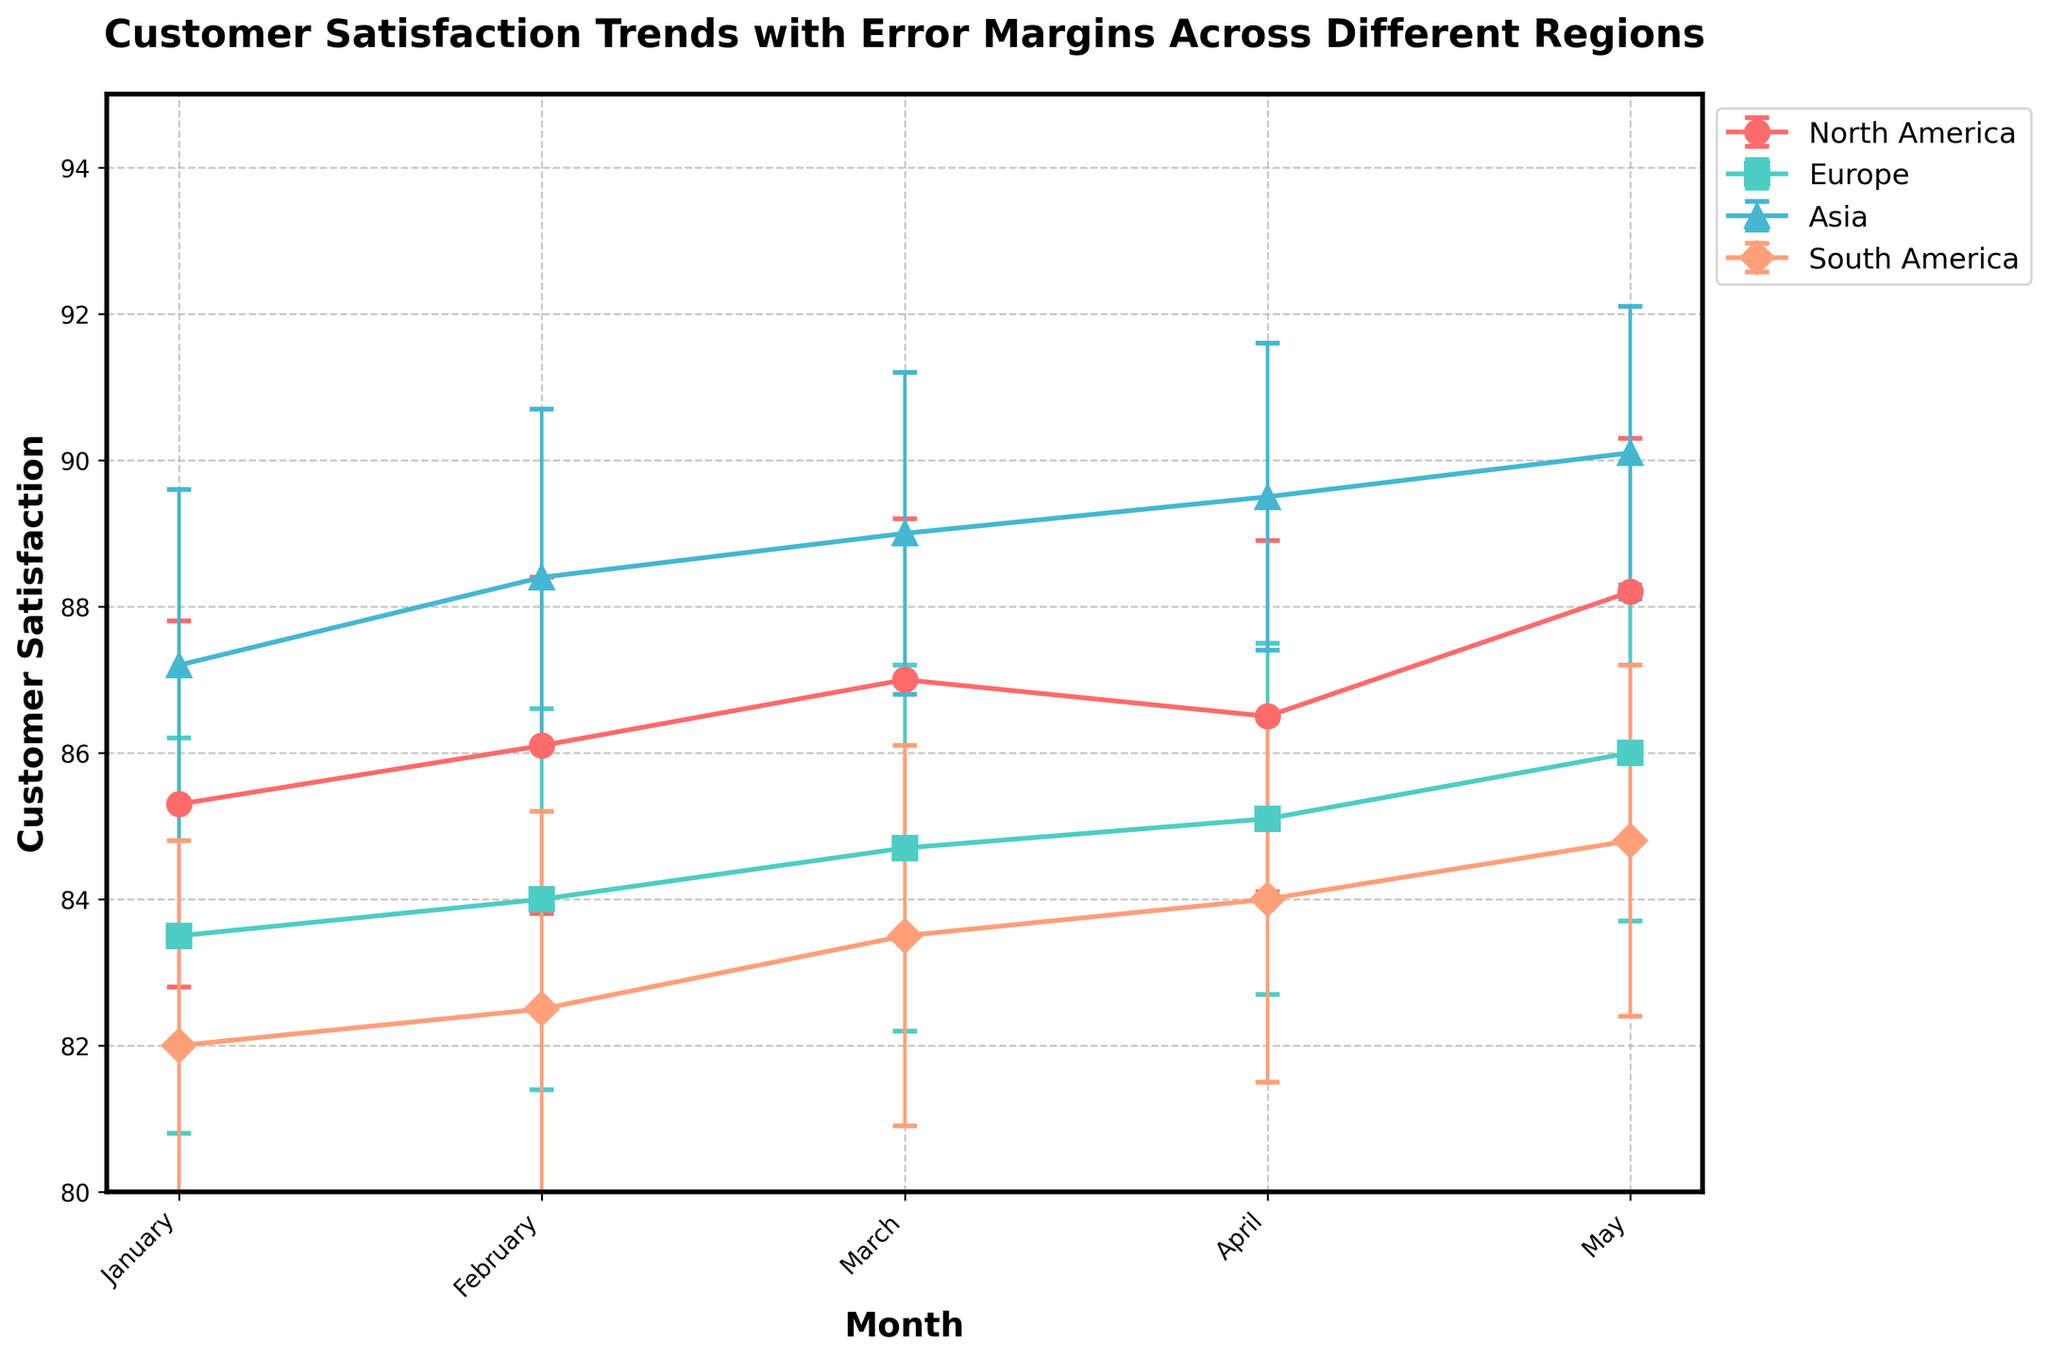What is the title of the plot? The title is usually a brief description that gives an overview of what the plot represents. It is found at the top of the plot. The title of this plot reads "Customer Satisfaction Trends with Error Margins Across Different Regions".
Answer: Customer Satisfaction Trends with Error Margins Across Different Regions Which region has the highest customer satisfaction in April? To find this, look at the data points corresponding to April for each region and compare the y-values (Customer Satisfaction). Asia has the highest y-value for April.
Answer: Asia What's the overall upward trend observed in any region? An upward trend means the customer satisfaction values are increasing over time. Observing the plot, Asia shows a consistent increase in customer satisfaction from January to May.
Answer: Asia What range of customer satisfaction scores are covered by the error margins for North America in January? Look at the January data point for North America and consider the error margins. The customer satisfaction is 85.3, and the error margin is 2.5. This makes the range from 85.3 - 2.5 = 82.8 to 85.3 + 2.5 = 87.8.
Answer: 82.8 to 87.8 How does the customer satisfaction in Europe in February compare to that in South America in the same month? Compare the y-values (Customer Satisfaction) for February for Europe and South America. Europe's satisfaction is higher at 84.0 compared to South America's 82.5.
Answer: Europe is higher Which region has the smallest error margin in May? Examine the error margins (error bars) for May across all regions. Asia has the smallest error margin of 2.0 in May.
Answer: Asia What is the average customer satisfaction in Asia over the five months? Sum the customer satisfaction values for Asia and divide by 5. (87.2 + 88.4 + 89.0 + 89.5 + 90.1) / 5 = 88.84.
Answer: 88.84 Which region showed a decline in customer satisfaction from March to April? Compare the customer satisfaction scores between March and April for each region. North America shows a decrease from 87.0 in March to 86.5 in April.
Answer: North America What is the range of customer satisfaction scores (including error margins) for Europe in March? The customer satisfaction score for Europe in March is 84.7 with an error margin of 2.5. The range is 84.7 - 2.5 to 84.7 + 2.5, which equals 82.2 to 87.2.
Answer: 82.2 to 87.2 